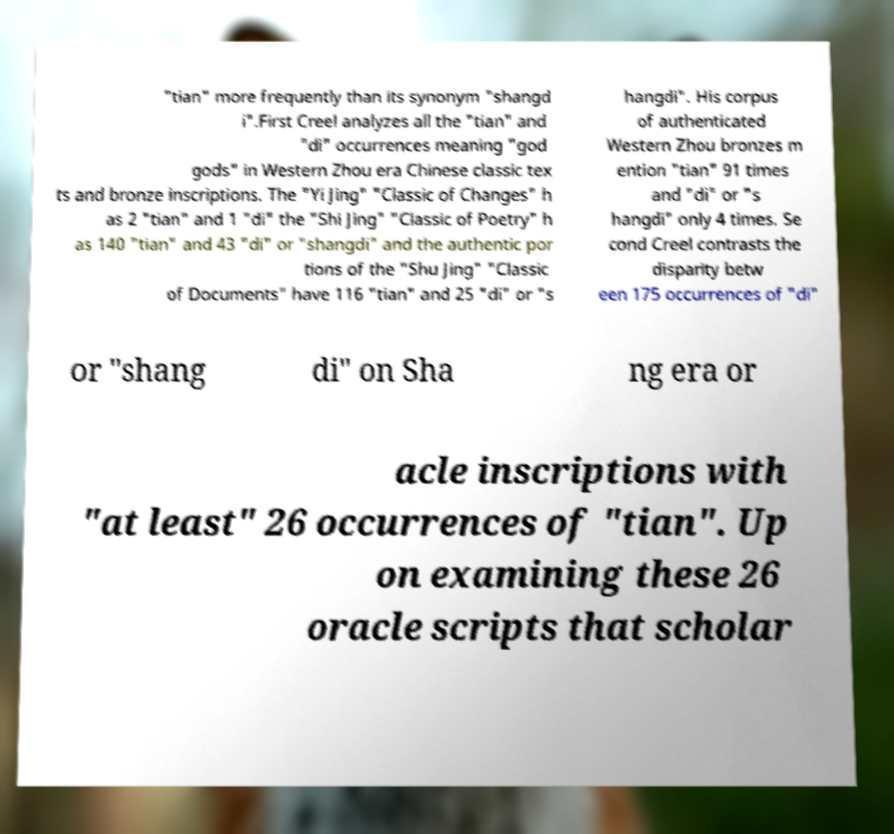Could you extract and type out the text from this image? "tian" more frequently than its synonym "shangd i".First Creel analyzes all the "tian" and "di" occurrences meaning "god gods" in Western Zhou era Chinese classic tex ts and bronze inscriptions. The "Yi Jing" "Classic of Changes" h as 2 "tian" and 1 "di" the "Shi Jing" "Classic of Poetry" h as 140 "tian" and 43 "di" or "shangdi" and the authentic por tions of the "Shu Jing" "Classic of Documents" have 116 "tian" and 25 "di" or "s hangdi". His corpus of authenticated Western Zhou bronzes m ention "tian" 91 times and "di" or "s hangdi" only 4 times. Se cond Creel contrasts the disparity betw een 175 occurrences of "di" or "shang di" on Sha ng era or acle inscriptions with "at least" 26 occurrences of "tian". Up on examining these 26 oracle scripts that scholar 